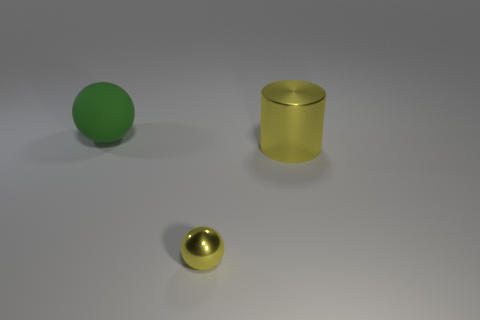Subtract all balls. How many objects are left? 1 Subtract 2 spheres. How many spheres are left? 0 Add 3 green matte balls. How many objects exist? 6 Add 2 big yellow metallic objects. How many big yellow metallic objects are left? 3 Add 1 balls. How many balls exist? 3 Subtract 0 brown cubes. How many objects are left? 3 Subtract all gray cylinders. Subtract all purple spheres. How many cylinders are left? 1 Subtract all red cylinders. How many yellow balls are left? 1 Subtract all tiny blue balls. Subtract all spheres. How many objects are left? 1 